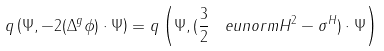<formula> <loc_0><loc_0><loc_500><loc_500>q \left ( \Psi , - 2 ( \Delta ^ { g } \phi ) \cdot \Psi \right ) = q \left ( \Psi , ( \frac { 3 } { 2 } \, \ e u n o r m { H } ^ { 2 } - \sigma ^ { H } ) \cdot \Psi \right )</formula> 